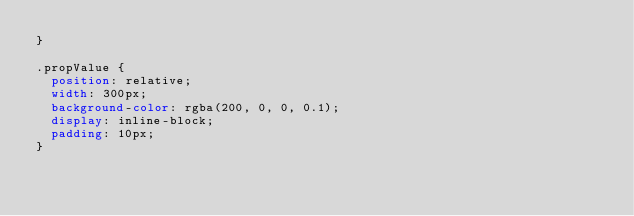<code> <loc_0><loc_0><loc_500><loc_500><_CSS_>}

.propValue {
  position: relative;
  width: 300px;
  background-color: rgba(200, 0, 0, 0.1);
  display: inline-block;
  padding: 10px;
}
</code> 